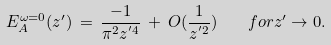Convert formula to latex. <formula><loc_0><loc_0><loc_500><loc_500>E _ { A } ^ { \omega = 0 } ( z ^ { \prime } ) \, = \, \frac { - 1 } { \pi ^ { 2 } z ^ { ^ { \prime } 4 } } \, + \, O ( \frac { 1 } { z ^ { ^ { \prime } 2 } } ) \quad f o r z ^ { \prime } \rightarrow 0 .</formula> 